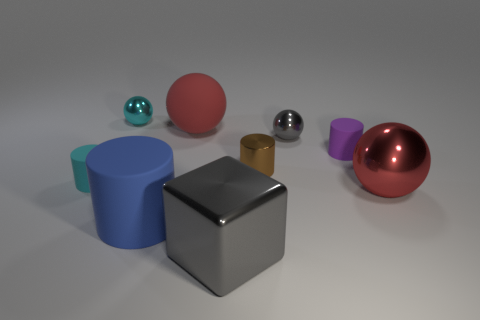Subtract all blue blocks. How many red spheres are left? 2 Add 1 large blue spheres. How many objects exist? 10 Subtract all tiny purple matte cylinders. How many cylinders are left? 3 Subtract all blocks. How many objects are left? 8 Subtract all purple cylinders. How many cylinders are left? 3 Subtract 0 purple blocks. How many objects are left? 9 Subtract all blue blocks. Subtract all green spheres. How many blocks are left? 1 Subtract all large shiny spheres. Subtract all small purple objects. How many objects are left? 7 Add 7 shiny cylinders. How many shiny cylinders are left? 8 Add 4 big brown things. How many big brown things exist? 4 